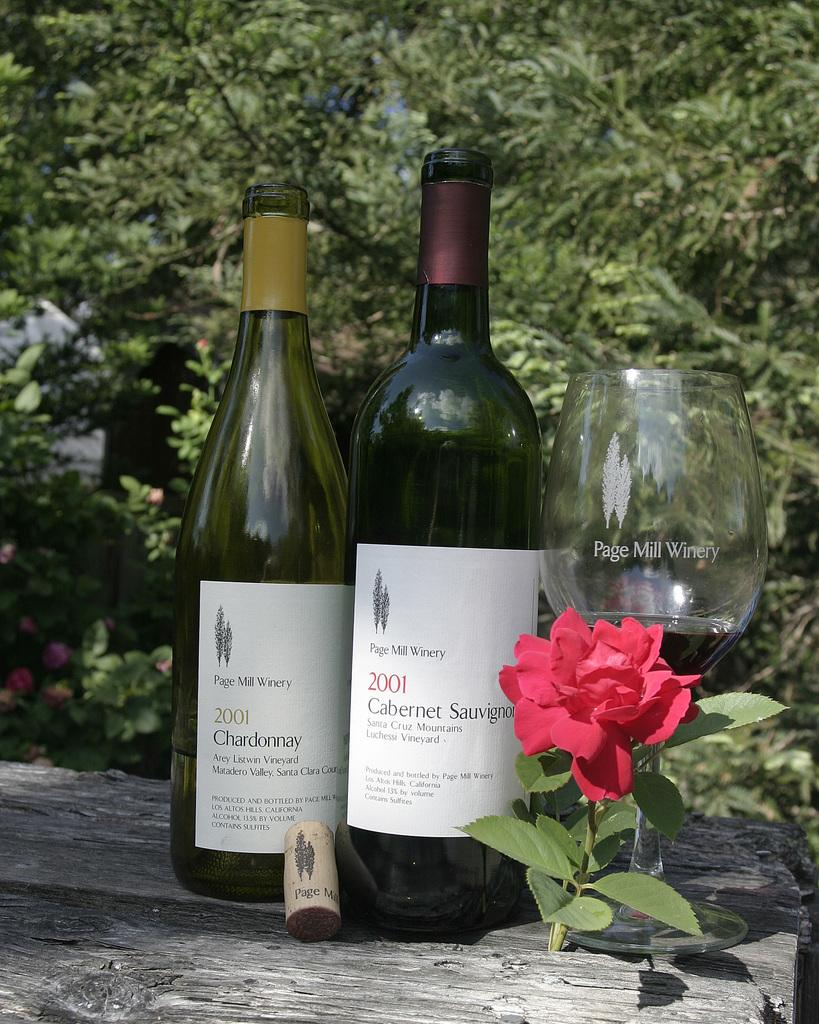<image>
Give a short and clear explanation of the subsequent image. Two bottles of wine dated 2001 from page mill winery. 